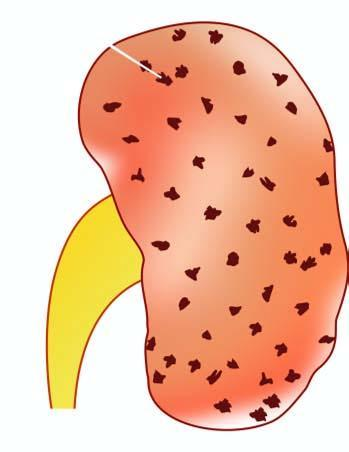s the infiltrate in the lumina enlarged in size and weight?
Answer the question using a single word or phrase. No 